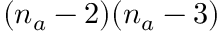<formula> <loc_0><loc_0><loc_500><loc_500>( n _ { a } - 2 ) ( n _ { a } - 3 )</formula> 